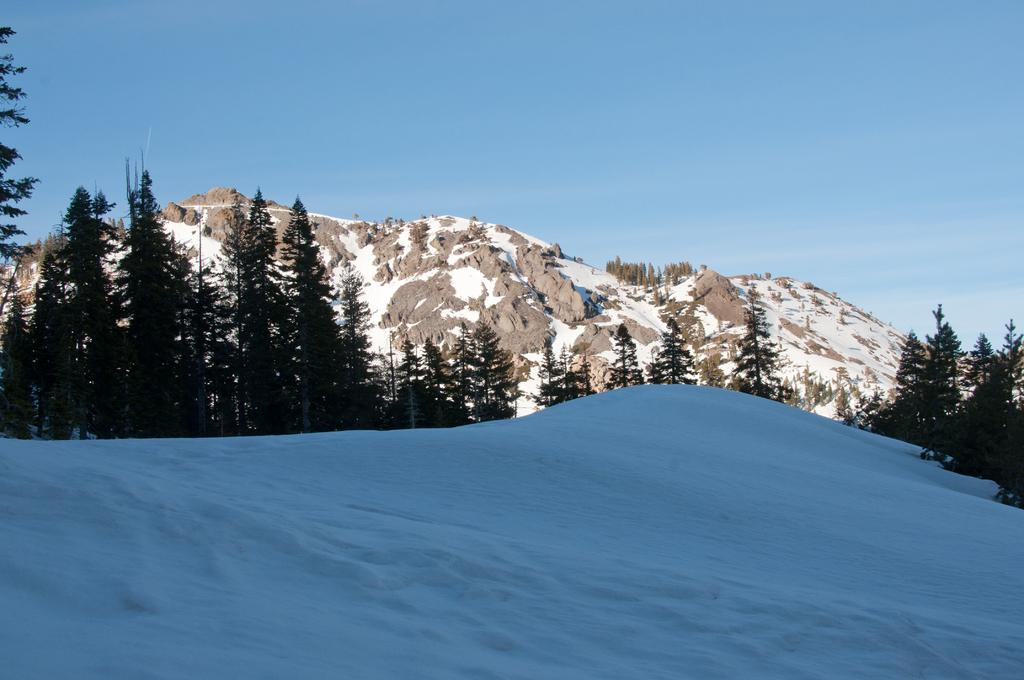What type of landscape is depicted in the image? The image features hills and trees. What is the weather like in the image? There is snow in the image, indicating a cold or wintry environment. What is the color and condition of the sky in the image? The sky is blue and cloudy in the image. Where is the nearest store to the group of people listening to music in the image? There are no people or music present in the image; it features hills, trees, snow, and a blue, cloudy sky. 